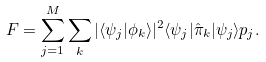Convert formula to latex. <formula><loc_0><loc_0><loc_500><loc_500>F = \sum _ { j = 1 } ^ { M } \sum _ { k } | \langle \psi _ { j } | \phi _ { k } \rangle | ^ { 2 } \langle \psi _ { j } | \hat { \pi } _ { k } | \psi _ { j } \rangle p _ { j } .</formula> 